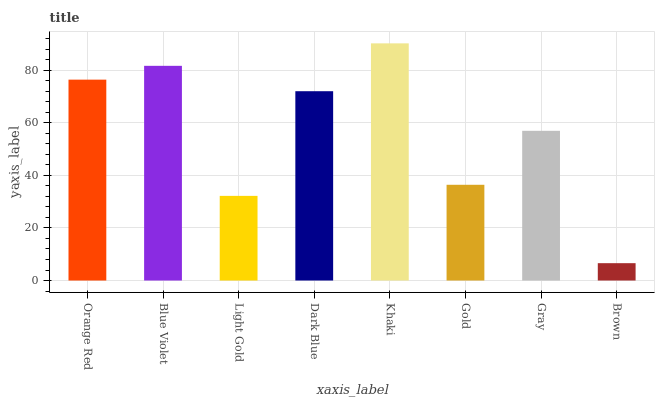Is Brown the minimum?
Answer yes or no. Yes. Is Khaki the maximum?
Answer yes or no. Yes. Is Blue Violet the minimum?
Answer yes or no. No. Is Blue Violet the maximum?
Answer yes or no. No. Is Blue Violet greater than Orange Red?
Answer yes or no. Yes. Is Orange Red less than Blue Violet?
Answer yes or no. Yes. Is Orange Red greater than Blue Violet?
Answer yes or no. No. Is Blue Violet less than Orange Red?
Answer yes or no. No. Is Dark Blue the high median?
Answer yes or no. Yes. Is Gray the low median?
Answer yes or no. Yes. Is Brown the high median?
Answer yes or no. No. Is Brown the low median?
Answer yes or no. No. 